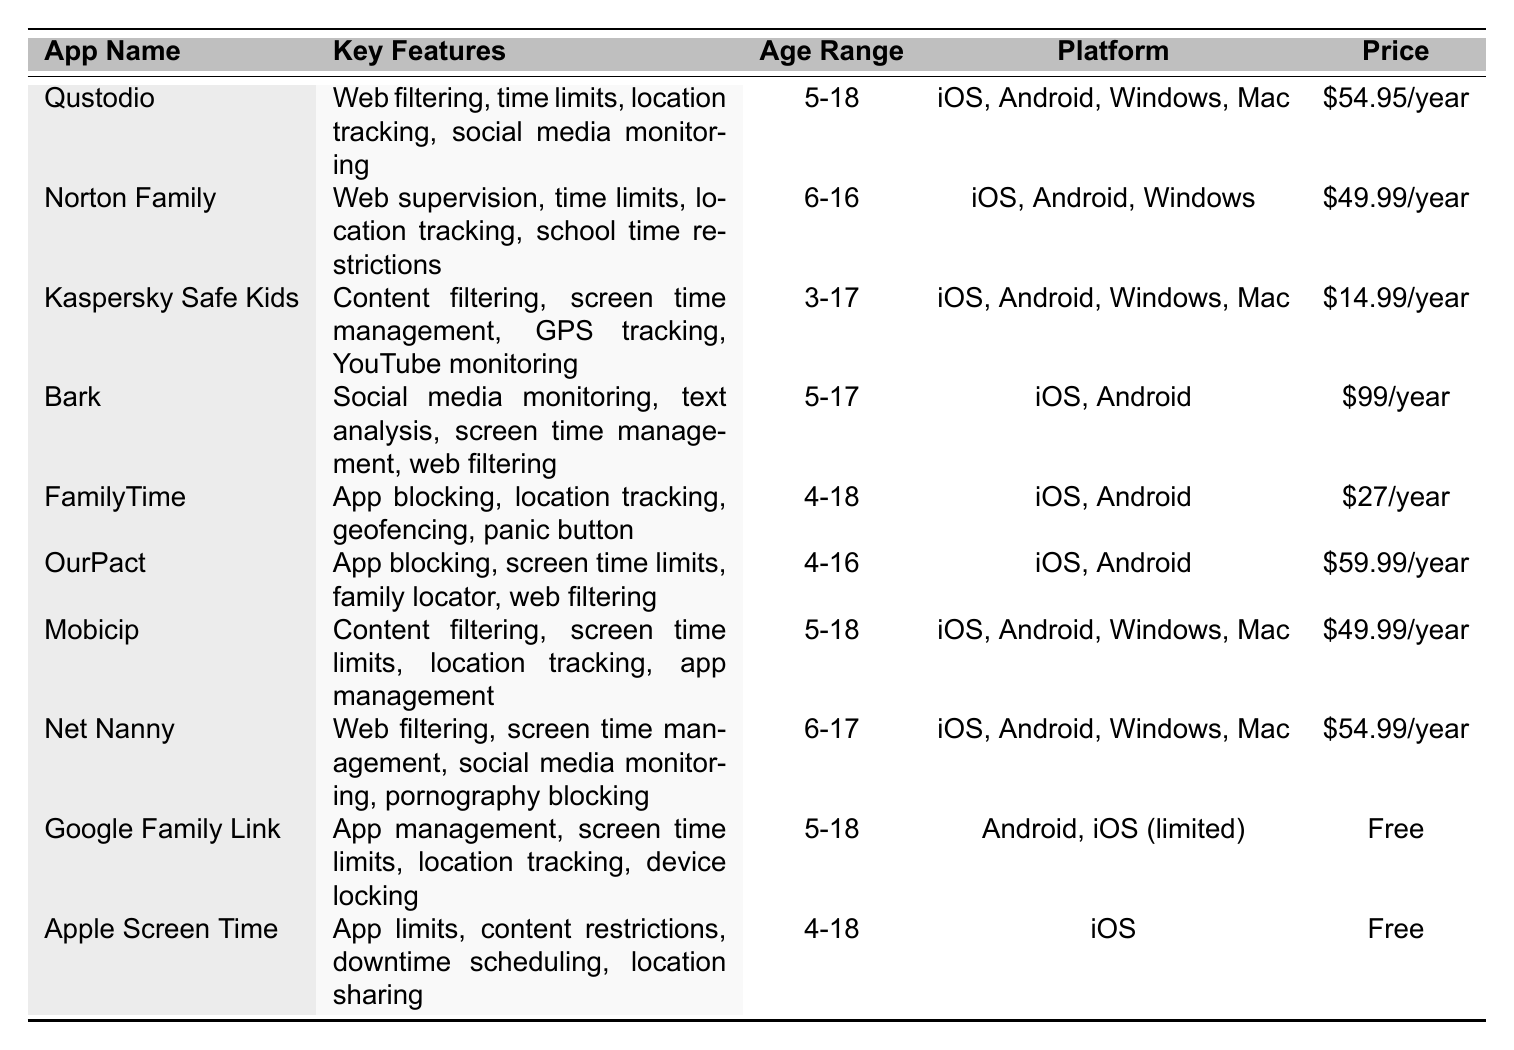What are the key features of Kaspersky Safe Kids? According to the table, the key features of Kaspersky Safe Kids are content filtering, screen time management, GPS tracking, and YouTube monitoring.
Answer: Content filtering, screen time management, GPS tracking, YouTube monitoring Which app has the highest price per year? By reviewing the pricing information in the table, Bark is the most expensive app at $99 per year, as all other prices are lower.
Answer: Bark at $99/year Is Google Family Link available on iOS? The table notes that Google Family Link is available on Android and has limited availability on iOS, indicating that it's not fully available on the iOS platform.
Answer: Yes, but limited What is the age range for FamilyTime? According to the table, FamilyTime is suitable for users aged 4 to 18.
Answer: 4-18 How many parental control apps offer location tracking as a feature? Counting from the table, the apps that offer location tracking are Qustodio, Norton Family, Kaspersky Safe Kids, Bark, FamilyTime, Mobicip, and Google Family Link, totaling 7 apps.
Answer: 7 apps Which parental control app has the lowest price, and what are its key features? From the pricing column, Kaspersky Safe Kids has the lowest price at $14.99 per year. Its key features include content filtering, screen time management, GPS tracking, and YouTube monitoring.
Answer: Kaspersky Safe Kids; content filtering, screen time management, GPS tracking, YouTube monitoring What is the average price of all apps listed? Summing the prices: $54.95, $49.99, $14.99, $99, $27, $59.99, $49.99, $54.99, $0, $0 gives a total of $404.90. There are 10 apps, so the average price is $404.90 / 10 = $40.49.
Answer: $40.49 Which apps have app blocking as a feature, and what is their price range? The apps with app blocking are FamilyTime ($27/year), OurPact ($59.99/year), and Bark ($99/year). The price range for these apps is $27 to $99.
Answer: $27 to $99 Are there any parental control apps available for free? The table indicates that both Google Family Link and Apple Screen Time are free options for parental control apps.
Answer: Yes, two apps are free Which app is available on the Windows platform and includes social media monitoring? Noting the table, Net Nanny is available on Windows and includes social media monitoring as one of its features.
Answer: Net Nanny 